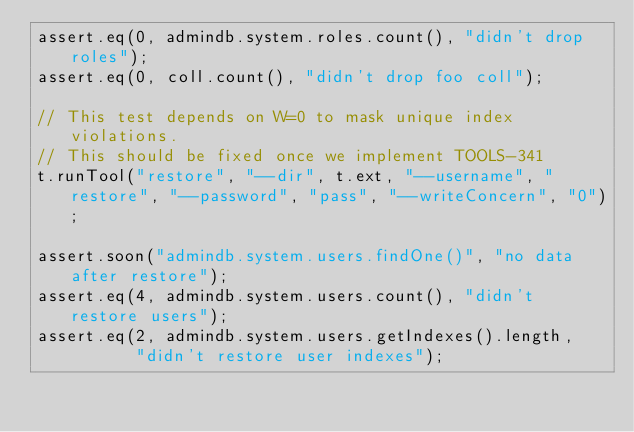Convert code to text. <code><loc_0><loc_0><loc_500><loc_500><_JavaScript_>assert.eq(0, admindb.system.roles.count(), "didn't drop roles");
assert.eq(0, coll.count(), "didn't drop foo coll");

// This test depends on W=0 to mask unique index violations.
// This should be fixed once we implement TOOLS-341
t.runTool("restore", "--dir", t.ext, "--username", "restore", "--password", "pass", "--writeConcern", "0");

assert.soon("admindb.system.users.findOne()", "no data after restore");
assert.eq(4, admindb.system.users.count(), "didn't restore users");
assert.eq(2, admindb.system.users.getIndexes().length,
          "didn't restore user indexes");</code> 